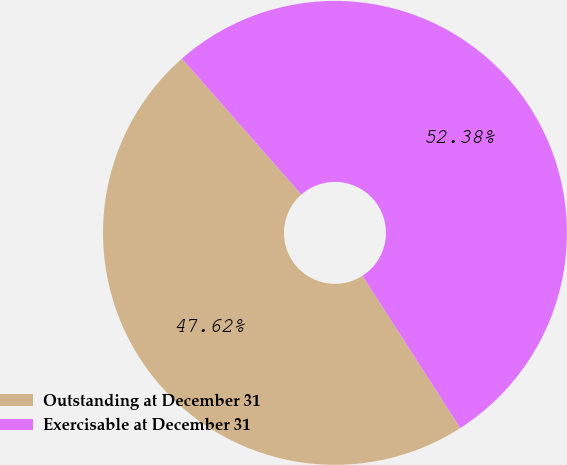<chart> <loc_0><loc_0><loc_500><loc_500><pie_chart><fcel>Outstanding at December 31<fcel>Exercisable at December 31<nl><fcel>47.62%<fcel>52.38%<nl></chart> 